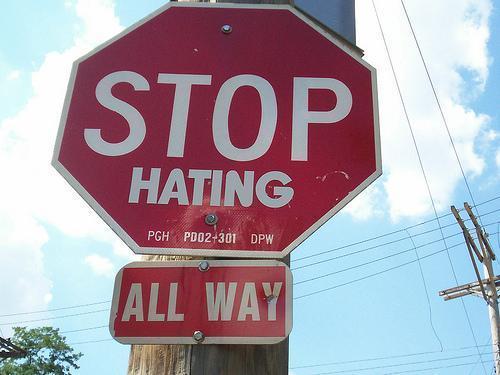How many signs are posted?
Give a very brief answer. 2. 